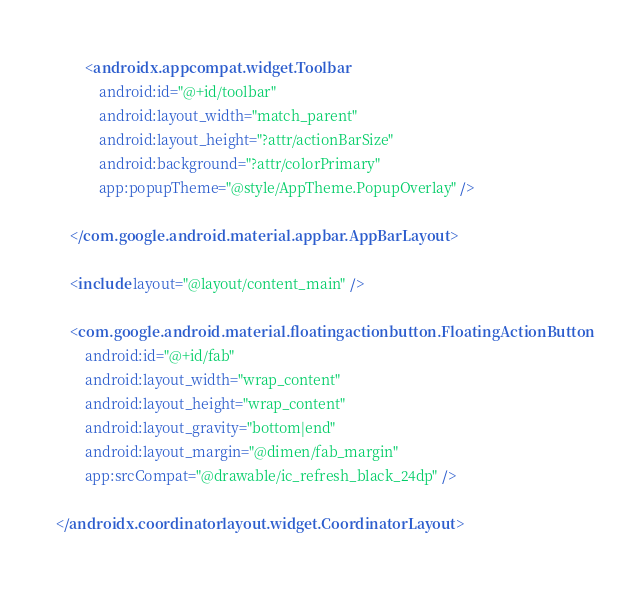Convert code to text. <code><loc_0><loc_0><loc_500><loc_500><_XML_>
        <androidx.appcompat.widget.Toolbar
            android:id="@+id/toolbar"
            android:layout_width="match_parent"
            android:layout_height="?attr/actionBarSize"
            android:background="?attr/colorPrimary"
            app:popupTheme="@style/AppTheme.PopupOverlay" />

    </com.google.android.material.appbar.AppBarLayout>

    <include layout="@layout/content_main" />

    <com.google.android.material.floatingactionbutton.FloatingActionButton
        android:id="@+id/fab"
        android:layout_width="wrap_content"
        android:layout_height="wrap_content"
        android:layout_gravity="bottom|end"
        android:layout_margin="@dimen/fab_margin"
        app:srcCompat="@drawable/ic_refresh_black_24dp" />

</androidx.coordinatorlayout.widget.CoordinatorLayout></code> 